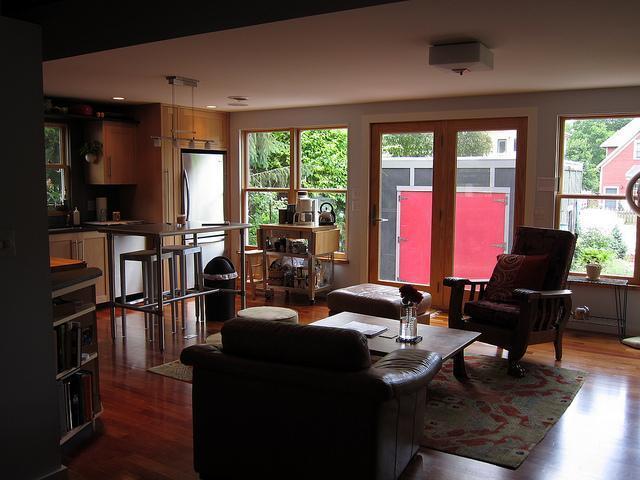How many stools are under the table?
Give a very brief answer. 2. How many chairs are in the photo?
Give a very brief answer. 2. 